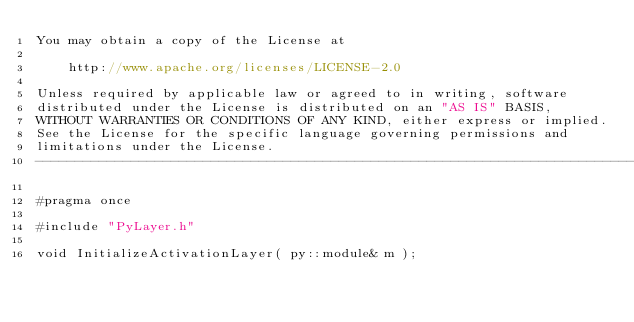Convert code to text. <code><loc_0><loc_0><loc_500><loc_500><_C_>You may obtain a copy of the License at

	http://www.apache.org/licenses/LICENSE-2.0

Unless required by applicable law or agreed to in writing, software
distributed under the License is distributed on an "AS IS" BASIS,
WITHOUT WARRANTIES OR CONDITIONS OF ANY KIND, either express or implied.
See the License for the specific language governing permissions and
limitations under the License.
--------------------------------------------------------------------------------------------------------------*/

#pragma once

#include "PyLayer.h"

void InitializeActivationLayer( py::module& m );</code> 